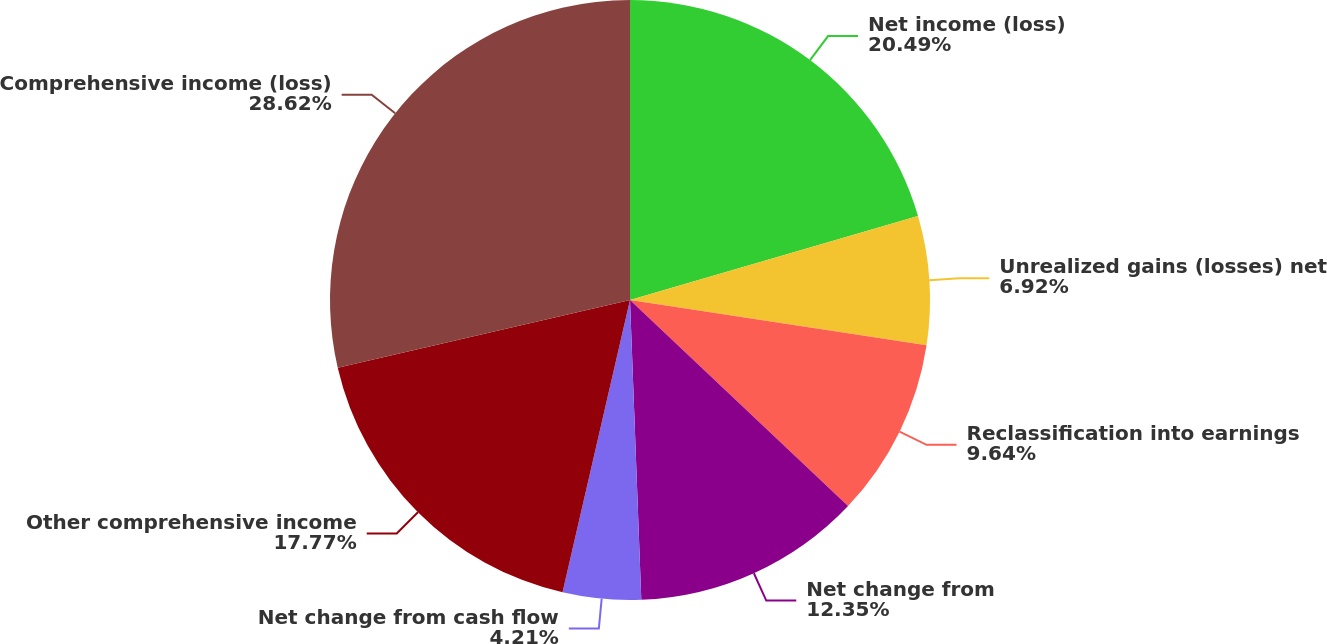Convert chart. <chart><loc_0><loc_0><loc_500><loc_500><pie_chart><fcel>Net income (loss)<fcel>Unrealized gains (losses) net<fcel>Reclassification into earnings<fcel>Net change from<fcel>Net change from cash flow<fcel>Other comprehensive income<fcel>Comprehensive income (loss)<nl><fcel>20.49%<fcel>6.92%<fcel>9.64%<fcel>12.35%<fcel>4.21%<fcel>17.77%<fcel>28.62%<nl></chart> 